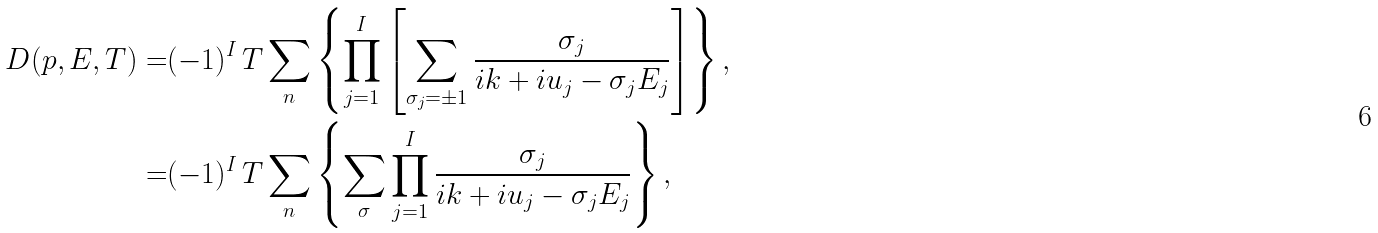Convert formula to latex. <formula><loc_0><loc_0><loc_500><loc_500>D ( p , E , T ) = & ( - 1 ) ^ { I } \, T \sum _ { n } \left \{ \prod _ { j = 1 } ^ { I } \left [ \sum _ { \sigma _ { j } = \pm 1 } \frac { \sigma _ { j } } { i k + i u _ { j } - \sigma _ { j } E _ { j } } \right ] \right \} , \\ = & ( - 1 ) ^ { I } \, T \sum _ { n } \left \{ \sum _ { \sigma } \prod _ { j = 1 } ^ { I } \frac { \sigma _ { j } } { i k + i u _ { j } - \sigma _ { j } E _ { j } } \right \} ,</formula> 